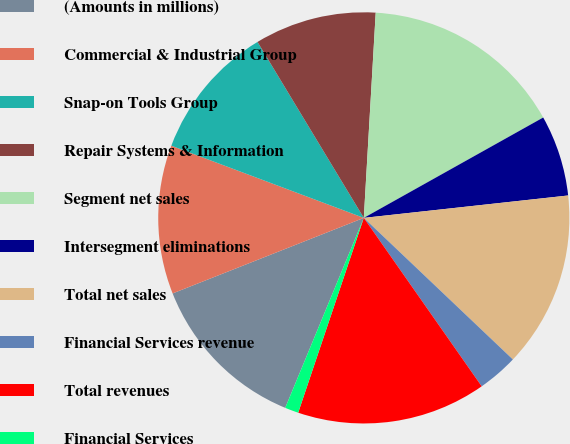Convert chart. <chart><loc_0><loc_0><loc_500><loc_500><pie_chart><fcel>(Amounts in millions)<fcel>Commercial & Industrial Group<fcel>Snap-on Tools Group<fcel>Repair Systems & Information<fcel>Segment net sales<fcel>Intersegment eliminations<fcel>Total net sales<fcel>Financial Services revenue<fcel>Total revenues<fcel>Financial Services<nl><fcel>12.77%<fcel>11.7%<fcel>10.64%<fcel>9.57%<fcel>15.96%<fcel>6.38%<fcel>13.83%<fcel>3.19%<fcel>14.89%<fcel>1.07%<nl></chart> 